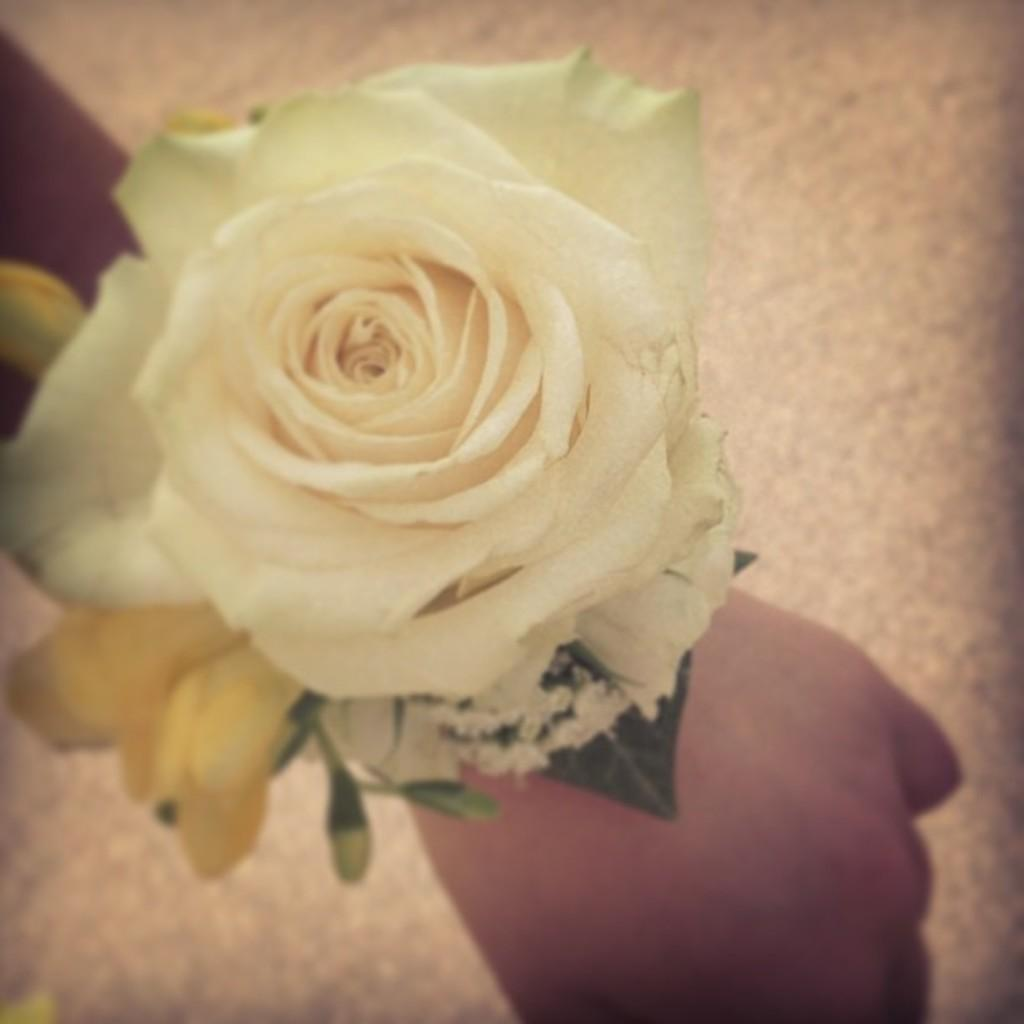What can be seen in the image related to a person's body part? There is a hand in the image. What type of flower is present in the image? There is a white color rose flower in the image. Is there any part of the rose flower's plant visible in the image? Yes, there is a leaf associated with the rose flower in the image. What type of fish can be seen swimming near the rose flower in the image? There is no fish present in the image; it only features a hand, a white color rose flower, and a leaf. 